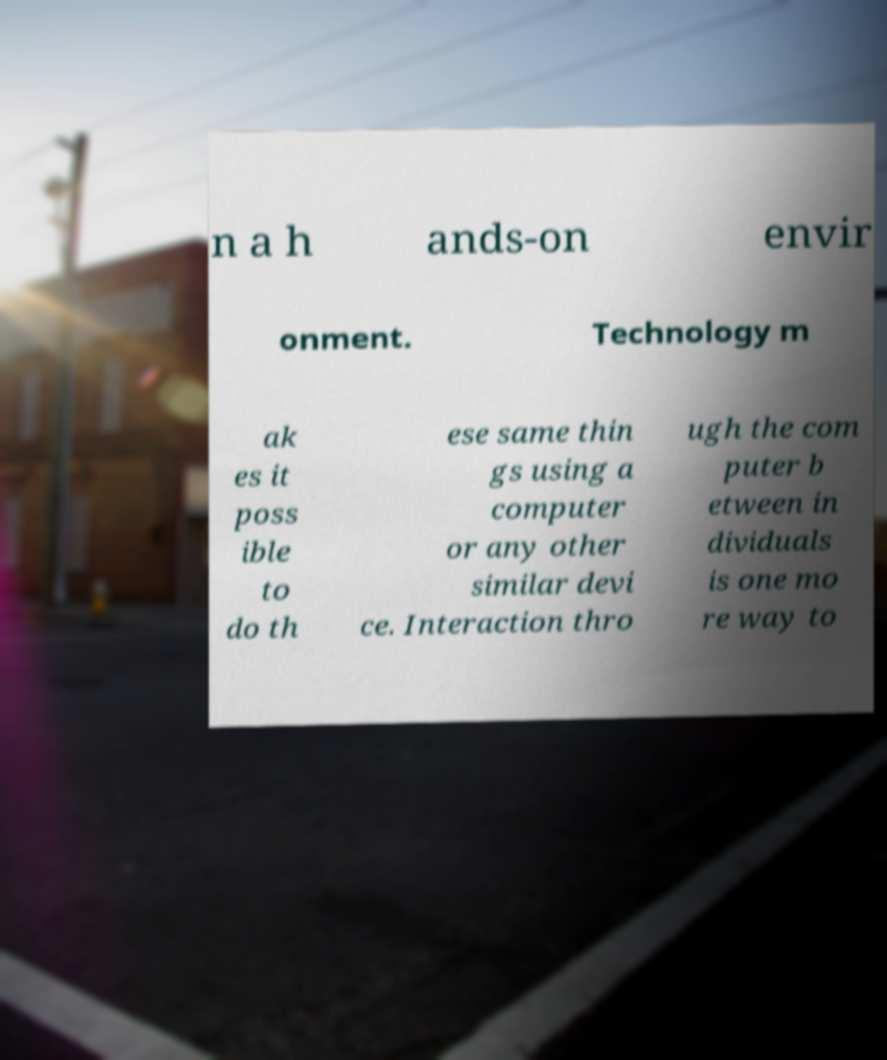Can you accurately transcribe the text from the provided image for me? n a h ands-on envir onment. Technology m ak es it poss ible to do th ese same thin gs using a computer or any other similar devi ce. Interaction thro ugh the com puter b etween in dividuals is one mo re way to 